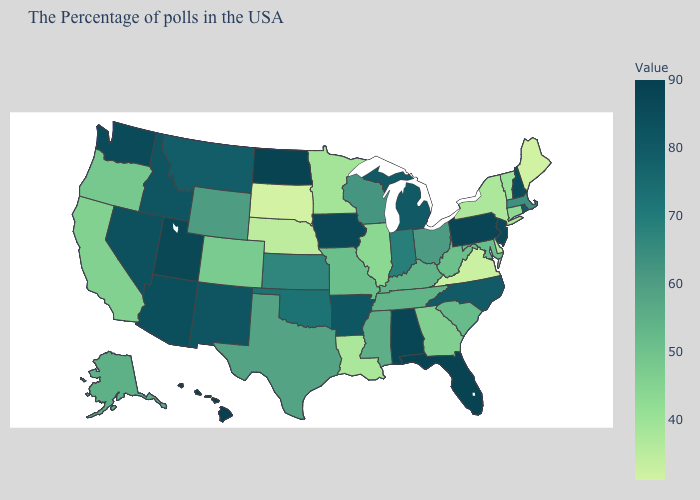Which states have the lowest value in the West?
Concise answer only. California. Does Indiana have a lower value than Pennsylvania?
Write a very short answer. Yes. Does Minnesota have a lower value than Massachusetts?
Answer briefly. Yes. Is the legend a continuous bar?
Concise answer only. Yes. 